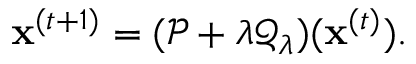Convert formula to latex. <formula><loc_0><loc_0><loc_500><loc_500>x ^ { ( t + 1 ) } = ( \mathcal { P } + \lambda \mathcal { Q } _ { \lambda } ) ( x ^ { ( t ) } ) .</formula> 